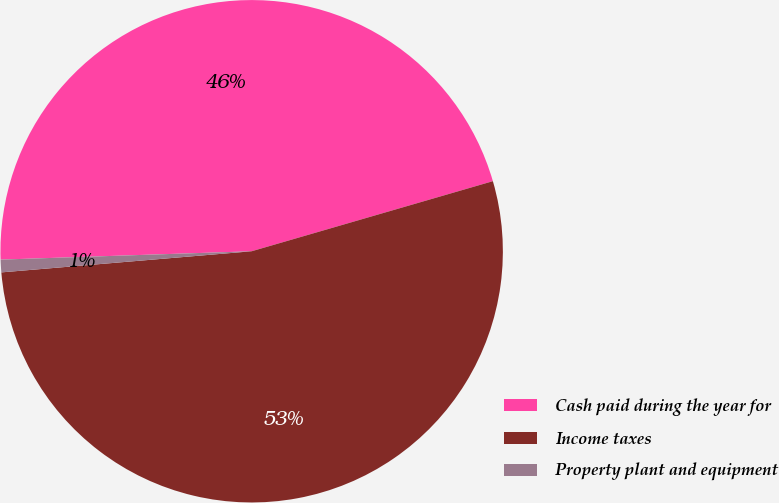Convert chart to OTSL. <chart><loc_0><loc_0><loc_500><loc_500><pie_chart><fcel>Cash paid during the year for<fcel>Income taxes<fcel>Property plant and equipment<nl><fcel>46.03%<fcel>53.16%<fcel>0.81%<nl></chart> 